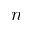Convert formula to latex. <formula><loc_0><loc_0><loc_500><loc_500>n</formula> 